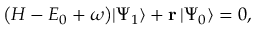<formula> <loc_0><loc_0><loc_500><loc_500>\begin{array} { r } { \left ( H - E _ { 0 } + \omega \right ) | \Psi _ { 1 } \rangle + r \, | \Psi _ { 0 } \rangle = 0 , } \end{array}</formula> 